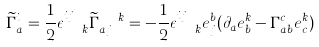<formula> <loc_0><loc_0><loc_500><loc_500>\widetilde { \Gamma } _ { a } ^ { i } = \frac { 1 } { 2 } \epsilon ^ { i j } _ { \ \ k } \widetilde { \Gamma } _ { a j } ^ { \ \ k } = - \frac { 1 } { 2 } \epsilon ^ { i j } _ { \ \ k } e ^ { b } _ { j } ( \partial _ { a } e _ { b } ^ { k } - \Gamma _ { a b } ^ { c } e _ { c } ^ { k } )</formula> 